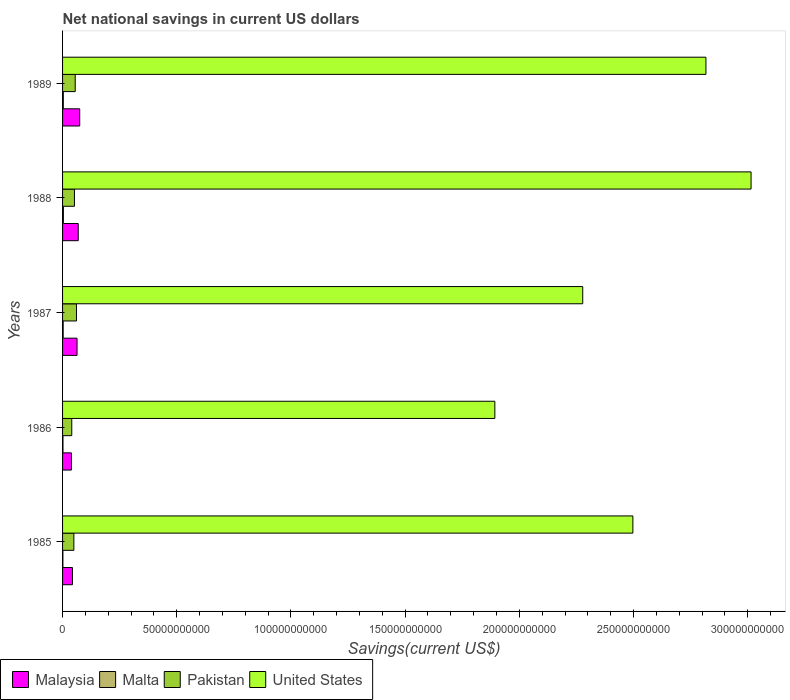How many groups of bars are there?
Provide a succinct answer. 5. How many bars are there on the 1st tick from the top?
Make the answer very short. 4. How many bars are there on the 1st tick from the bottom?
Offer a terse response. 4. In how many cases, is the number of bars for a given year not equal to the number of legend labels?
Make the answer very short. 0. What is the net national savings in Pakistan in 1987?
Keep it short and to the point. 6.09e+09. Across all years, what is the maximum net national savings in Pakistan?
Provide a succinct answer. 6.09e+09. Across all years, what is the minimum net national savings in Malta?
Make the answer very short. 1.41e+08. In which year was the net national savings in Pakistan minimum?
Ensure brevity in your answer.  1986. What is the total net national savings in United States in the graph?
Your response must be concise. 1.25e+12. What is the difference between the net national savings in Pakistan in 1987 and that in 1989?
Give a very brief answer. 5.49e+08. What is the difference between the net national savings in Malaysia in 1989 and the net national savings in United States in 1986?
Your response must be concise. -1.82e+11. What is the average net national savings in Malaysia per year?
Provide a short and direct response. 5.79e+09. In the year 1987, what is the difference between the net national savings in Pakistan and net national savings in Malta?
Keep it short and to the point. 5.83e+09. In how many years, is the net national savings in Malta greater than 70000000000 US$?
Offer a very short reply. 0. What is the ratio of the net national savings in Malaysia in 1988 to that in 1989?
Provide a short and direct response. 0.91. Is the net national savings in Malaysia in 1986 less than that in 1988?
Offer a very short reply. Yes. What is the difference between the highest and the second highest net national savings in Pakistan?
Your response must be concise. 5.49e+08. What is the difference between the highest and the lowest net national savings in Malaysia?
Your answer should be very brief. 3.62e+09. Is the sum of the net national savings in United States in 1986 and 1989 greater than the maximum net national savings in Malaysia across all years?
Offer a terse response. Yes. What does the 3rd bar from the bottom in 1986 represents?
Your answer should be compact. Pakistan. Is it the case that in every year, the sum of the net national savings in United States and net national savings in Malta is greater than the net national savings in Malaysia?
Make the answer very short. Yes. How many years are there in the graph?
Your answer should be very brief. 5. What is the difference between two consecutive major ticks on the X-axis?
Keep it short and to the point. 5.00e+1. Where does the legend appear in the graph?
Keep it short and to the point. Bottom left. What is the title of the graph?
Give a very brief answer. Net national savings in current US dollars. What is the label or title of the X-axis?
Give a very brief answer. Savings(current US$). What is the Savings(current US$) in Malaysia in 1985?
Offer a very short reply. 4.33e+09. What is the Savings(current US$) in Malta in 1985?
Keep it short and to the point. 1.41e+08. What is the Savings(current US$) in Pakistan in 1985?
Provide a succinct answer. 4.95e+09. What is the Savings(current US$) of United States in 1985?
Provide a succinct answer. 2.50e+11. What is the Savings(current US$) in Malaysia in 1986?
Give a very brief answer. 3.89e+09. What is the Savings(current US$) of Malta in 1986?
Give a very brief answer. 1.83e+08. What is the Savings(current US$) of Pakistan in 1986?
Provide a succinct answer. 4.03e+09. What is the Savings(current US$) in United States in 1986?
Provide a short and direct response. 1.89e+11. What is the Savings(current US$) in Malaysia in 1987?
Offer a very short reply. 6.34e+09. What is the Savings(current US$) in Malta in 1987?
Offer a very short reply. 2.65e+08. What is the Savings(current US$) in Pakistan in 1987?
Provide a short and direct response. 6.09e+09. What is the Savings(current US$) in United States in 1987?
Your answer should be very brief. 2.28e+11. What is the Savings(current US$) in Malaysia in 1988?
Provide a succinct answer. 6.86e+09. What is the Savings(current US$) of Malta in 1988?
Your response must be concise. 3.62e+08. What is the Savings(current US$) in Pakistan in 1988?
Your response must be concise. 5.20e+09. What is the Savings(current US$) in United States in 1988?
Your answer should be compact. 3.01e+11. What is the Savings(current US$) of Malaysia in 1989?
Give a very brief answer. 7.51e+09. What is the Savings(current US$) in Malta in 1989?
Your response must be concise. 3.23e+08. What is the Savings(current US$) in Pakistan in 1989?
Your answer should be very brief. 5.54e+09. What is the Savings(current US$) in United States in 1989?
Provide a short and direct response. 2.82e+11. Across all years, what is the maximum Savings(current US$) in Malaysia?
Your answer should be compact. 7.51e+09. Across all years, what is the maximum Savings(current US$) in Malta?
Give a very brief answer. 3.62e+08. Across all years, what is the maximum Savings(current US$) of Pakistan?
Provide a succinct answer. 6.09e+09. Across all years, what is the maximum Savings(current US$) in United States?
Your answer should be compact. 3.01e+11. Across all years, what is the minimum Savings(current US$) of Malaysia?
Your answer should be very brief. 3.89e+09. Across all years, what is the minimum Savings(current US$) of Malta?
Ensure brevity in your answer.  1.41e+08. Across all years, what is the minimum Savings(current US$) of Pakistan?
Your answer should be compact. 4.03e+09. Across all years, what is the minimum Savings(current US$) of United States?
Ensure brevity in your answer.  1.89e+11. What is the total Savings(current US$) in Malaysia in the graph?
Make the answer very short. 2.89e+1. What is the total Savings(current US$) of Malta in the graph?
Your answer should be compact. 1.28e+09. What is the total Savings(current US$) of Pakistan in the graph?
Ensure brevity in your answer.  2.58e+1. What is the total Savings(current US$) in United States in the graph?
Provide a short and direct response. 1.25e+12. What is the difference between the Savings(current US$) in Malaysia in 1985 and that in 1986?
Your response must be concise. 4.40e+08. What is the difference between the Savings(current US$) in Malta in 1985 and that in 1986?
Provide a short and direct response. -4.16e+07. What is the difference between the Savings(current US$) in Pakistan in 1985 and that in 1986?
Make the answer very short. 9.20e+08. What is the difference between the Savings(current US$) of United States in 1985 and that in 1986?
Your answer should be compact. 6.04e+1. What is the difference between the Savings(current US$) of Malaysia in 1985 and that in 1987?
Provide a short and direct response. -2.01e+09. What is the difference between the Savings(current US$) in Malta in 1985 and that in 1987?
Your response must be concise. -1.24e+08. What is the difference between the Savings(current US$) in Pakistan in 1985 and that in 1987?
Give a very brief answer. -1.14e+09. What is the difference between the Savings(current US$) of United States in 1985 and that in 1987?
Your answer should be very brief. 2.20e+1. What is the difference between the Savings(current US$) in Malaysia in 1985 and that in 1988?
Your answer should be compact. -2.53e+09. What is the difference between the Savings(current US$) in Malta in 1985 and that in 1988?
Ensure brevity in your answer.  -2.21e+08. What is the difference between the Savings(current US$) of Pakistan in 1985 and that in 1988?
Your answer should be compact. -2.55e+08. What is the difference between the Savings(current US$) of United States in 1985 and that in 1988?
Provide a short and direct response. -5.17e+1. What is the difference between the Savings(current US$) in Malaysia in 1985 and that in 1989?
Provide a short and direct response. -3.18e+09. What is the difference between the Savings(current US$) in Malta in 1985 and that in 1989?
Offer a very short reply. -1.82e+08. What is the difference between the Savings(current US$) of Pakistan in 1985 and that in 1989?
Your answer should be very brief. -5.95e+08. What is the difference between the Savings(current US$) in United States in 1985 and that in 1989?
Provide a short and direct response. -3.20e+1. What is the difference between the Savings(current US$) of Malaysia in 1986 and that in 1987?
Your response must be concise. -2.45e+09. What is the difference between the Savings(current US$) in Malta in 1986 and that in 1987?
Your answer should be compact. -8.21e+07. What is the difference between the Savings(current US$) in Pakistan in 1986 and that in 1987?
Ensure brevity in your answer.  -2.06e+09. What is the difference between the Savings(current US$) of United States in 1986 and that in 1987?
Offer a terse response. -3.85e+1. What is the difference between the Savings(current US$) of Malaysia in 1986 and that in 1988?
Your answer should be compact. -2.97e+09. What is the difference between the Savings(current US$) in Malta in 1986 and that in 1988?
Offer a terse response. -1.79e+08. What is the difference between the Savings(current US$) in Pakistan in 1986 and that in 1988?
Offer a very short reply. -1.18e+09. What is the difference between the Savings(current US$) in United States in 1986 and that in 1988?
Provide a succinct answer. -1.12e+11. What is the difference between the Savings(current US$) of Malaysia in 1986 and that in 1989?
Your answer should be compact. -3.62e+09. What is the difference between the Savings(current US$) in Malta in 1986 and that in 1989?
Offer a terse response. -1.40e+08. What is the difference between the Savings(current US$) of Pakistan in 1986 and that in 1989?
Your response must be concise. -1.52e+09. What is the difference between the Savings(current US$) in United States in 1986 and that in 1989?
Your answer should be compact. -9.24e+1. What is the difference between the Savings(current US$) of Malaysia in 1987 and that in 1988?
Offer a terse response. -5.20e+08. What is the difference between the Savings(current US$) in Malta in 1987 and that in 1988?
Make the answer very short. -9.72e+07. What is the difference between the Savings(current US$) in Pakistan in 1987 and that in 1988?
Provide a succinct answer. 8.89e+08. What is the difference between the Savings(current US$) in United States in 1987 and that in 1988?
Offer a terse response. -7.37e+1. What is the difference between the Savings(current US$) in Malaysia in 1987 and that in 1989?
Make the answer very short. -1.17e+09. What is the difference between the Savings(current US$) in Malta in 1987 and that in 1989?
Your answer should be compact. -5.83e+07. What is the difference between the Savings(current US$) of Pakistan in 1987 and that in 1989?
Your answer should be compact. 5.49e+08. What is the difference between the Savings(current US$) of United States in 1987 and that in 1989?
Your response must be concise. -5.39e+1. What is the difference between the Savings(current US$) in Malaysia in 1988 and that in 1989?
Keep it short and to the point. -6.50e+08. What is the difference between the Savings(current US$) of Malta in 1988 and that in 1989?
Offer a very short reply. 3.90e+07. What is the difference between the Savings(current US$) of Pakistan in 1988 and that in 1989?
Ensure brevity in your answer.  -3.40e+08. What is the difference between the Savings(current US$) of United States in 1988 and that in 1989?
Give a very brief answer. 1.98e+1. What is the difference between the Savings(current US$) in Malaysia in 1985 and the Savings(current US$) in Malta in 1986?
Offer a very short reply. 4.15e+09. What is the difference between the Savings(current US$) in Malaysia in 1985 and the Savings(current US$) in Pakistan in 1986?
Your answer should be very brief. 3.06e+08. What is the difference between the Savings(current US$) in Malaysia in 1985 and the Savings(current US$) in United States in 1986?
Your answer should be compact. -1.85e+11. What is the difference between the Savings(current US$) of Malta in 1985 and the Savings(current US$) of Pakistan in 1986?
Offer a terse response. -3.89e+09. What is the difference between the Savings(current US$) in Malta in 1985 and the Savings(current US$) in United States in 1986?
Provide a succinct answer. -1.89e+11. What is the difference between the Savings(current US$) in Pakistan in 1985 and the Savings(current US$) in United States in 1986?
Your answer should be very brief. -1.84e+11. What is the difference between the Savings(current US$) of Malaysia in 1985 and the Savings(current US$) of Malta in 1987?
Keep it short and to the point. 4.07e+09. What is the difference between the Savings(current US$) of Malaysia in 1985 and the Savings(current US$) of Pakistan in 1987?
Keep it short and to the point. -1.76e+09. What is the difference between the Savings(current US$) of Malaysia in 1985 and the Savings(current US$) of United States in 1987?
Make the answer very short. -2.23e+11. What is the difference between the Savings(current US$) of Malta in 1985 and the Savings(current US$) of Pakistan in 1987?
Provide a short and direct response. -5.95e+09. What is the difference between the Savings(current US$) of Malta in 1985 and the Savings(current US$) of United States in 1987?
Your answer should be compact. -2.28e+11. What is the difference between the Savings(current US$) in Pakistan in 1985 and the Savings(current US$) in United States in 1987?
Your response must be concise. -2.23e+11. What is the difference between the Savings(current US$) of Malaysia in 1985 and the Savings(current US$) of Malta in 1988?
Ensure brevity in your answer.  3.97e+09. What is the difference between the Savings(current US$) of Malaysia in 1985 and the Savings(current US$) of Pakistan in 1988?
Provide a short and direct response. -8.70e+08. What is the difference between the Savings(current US$) of Malaysia in 1985 and the Savings(current US$) of United States in 1988?
Your answer should be compact. -2.97e+11. What is the difference between the Savings(current US$) of Malta in 1985 and the Savings(current US$) of Pakistan in 1988?
Offer a terse response. -5.06e+09. What is the difference between the Savings(current US$) in Malta in 1985 and the Savings(current US$) in United States in 1988?
Make the answer very short. -3.01e+11. What is the difference between the Savings(current US$) of Pakistan in 1985 and the Savings(current US$) of United States in 1988?
Ensure brevity in your answer.  -2.97e+11. What is the difference between the Savings(current US$) of Malaysia in 1985 and the Savings(current US$) of Malta in 1989?
Your response must be concise. 4.01e+09. What is the difference between the Savings(current US$) in Malaysia in 1985 and the Savings(current US$) in Pakistan in 1989?
Your answer should be compact. -1.21e+09. What is the difference between the Savings(current US$) in Malaysia in 1985 and the Savings(current US$) in United States in 1989?
Provide a short and direct response. -2.77e+11. What is the difference between the Savings(current US$) in Malta in 1985 and the Savings(current US$) in Pakistan in 1989?
Give a very brief answer. -5.40e+09. What is the difference between the Savings(current US$) of Malta in 1985 and the Savings(current US$) of United States in 1989?
Ensure brevity in your answer.  -2.82e+11. What is the difference between the Savings(current US$) in Pakistan in 1985 and the Savings(current US$) in United States in 1989?
Keep it short and to the point. -2.77e+11. What is the difference between the Savings(current US$) of Malaysia in 1986 and the Savings(current US$) of Malta in 1987?
Provide a short and direct response. 3.63e+09. What is the difference between the Savings(current US$) in Malaysia in 1986 and the Savings(current US$) in Pakistan in 1987?
Your answer should be compact. -2.20e+09. What is the difference between the Savings(current US$) of Malaysia in 1986 and the Savings(current US$) of United States in 1987?
Your answer should be very brief. -2.24e+11. What is the difference between the Savings(current US$) in Malta in 1986 and the Savings(current US$) in Pakistan in 1987?
Ensure brevity in your answer.  -5.91e+09. What is the difference between the Savings(current US$) of Malta in 1986 and the Savings(current US$) of United States in 1987?
Keep it short and to the point. -2.28e+11. What is the difference between the Savings(current US$) of Pakistan in 1986 and the Savings(current US$) of United States in 1987?
Ensure brevity in your answer.  -2.24e+11. What is the difference between the Savings(current US$) of Malaysia in 1986 and the Savings(current US$) of Malta in 1988?
Offer a very short reply. 3.53e+09. What is the difference between the Savings(current US$) in Malaysia in 1986 and the Savings(current US$) in Pakistan in 1988?
Make the answer very short. -1.31e+09. What is the difference between the Savings(current US$) of Malaysia in 1986 and the Savings(current US$) of United States in 1988?
Your answer should be compact. -2.98e+11. What is the difference between the Savings(current US$) in Malta in 1986 and the Savings(current US$) in Pakistan in 1988?
Keep it short and to the point. -5.02e+09. What is the difference between the Savings(current US$) in Malta in 1986 and the Savings(current US$) in United States in 1988?
Your response must be concise. -3.01e+11. What is the difference between the Savings(current US$) in Pakistan in 1986 and the Savings(current US$) in United States in 1988?
Give a very brief answer. -2.97e+11. What is the difference between the Savings(current US$) of Malaysia in 1986 and the Savings(current US$) of Malta in 1989?
Keep it short and to the point. 3.57e+09. What is the difference between the Savings(current US$) in Malaysia in 1986 and the Savings(current US$) in Pakistan in 1989?
Your response must be concise. -1.65e+09. What is the difference between the Savings(current US$) of Malaysia in 1986 and the Savings(current US$) of United States in 1989?
Your response must be concise. -2.78e+11. What is the difference between the Savings(current US$) of Malta in 1986 and the Savings(current US$) of Pakistan in 1989?
Ensure brevity in your answer.  -5.36e+09. What is the difference between the Savings(current US$) of Malta in 1986 and the Savings(current US$) of United States in 1989?
Offer a very short reply. -2.82e+11. What is the difference between the Savings(current US$) in Pakistan in 1986 and the Savings(current US$) in United States in 1989?
Offer a terse response. -2.78e+11. What is the difference between the Savings(current US$) of Malaysia in 1987 and the Savings(current US$) of Malta in 1988?
Give a very brief answer. 5.98e+09. What is the difference between the Savings(current US$) of Malaysia in 1987 and the Savings(current US$) of Pakistan in 1988?
Your answer should be compact. 1.14e+09. What is the difference between the Savings(current US$) of Malaysia in 1987 and the Savings(current US$) of United States in 1988?
Your response must be concise. -2.95e+11. What is the difference between the Savings(current US$) of Malta in 1987 and the Savings(current US$) of Pakistan in 1988?
Provide a succinct answer. -4.94e+09. What is the difference between the Savings(current US$) of Malta in 1987 and the Savings(current US$) of United States in 1988?
Your response must be concise. -3.01e+11. What is the difference between the Savings(current US$) in Pakistan in 1987 and the Savings(current US$) in United States in 1988?
Give a very brief answer. -2.95e+11. What is the difference between the Savings(current US$) in Malaysia in 1987 and the Savings(current US$) in Malta in 1989?
Your answer should be very brief. 6.02e+09. What is the difference between the Savings(current US$) of Malaysia in 1987 and the Savings(current US$) of Pakistan in 1989?
Your response must be concise. 7.97e+08. What is the difference between the Savings(current US$) of Malaysia in 1987 and the Savings(current US$) of United States in 1989?
Provide a short and direct response. -2.75e+11. What is the difference between the Savings(current US$) in Malta in 1987 and the Savings(current US$) in Pakistan in 1989?
Offer a terse response. -5.28e+09. What is the difference between the Savings(current US$) of Malta in 1987 and the Savings(current US$) of United States in 1989?
Provide a short and direct response. -2.81e+11. What is the difference between the Savings(current US$) in Pakistan in 1987 and the Savings(current US$) in United States in 1989?
Your response must be concise. -2.76e+11. What is the difference between the Savings(current US$) of Malaysia in 1988 and the Savings(current US$) of Malta in 1989?
Provide a short and direct response. 6.54e+09. What is the difference between the Savings(current US$) in Malaysia in 1988 and the Savings(current US$) in Pakistan in 1989?
Offer a terse response. 1.32e+09. What is the difference between the Savings(current US$) in Malaysia in 1988 and the Savings(current US$) in United States in 1989?
Your answer should be compact. -2.75e+11. What is the difference between the Savings(current US$) in Malta in 1988 and the Savings(current US$) in Pakistan in 1989?
Your answer should be very brief. -5.18e+09. What is the difference between the Savings(current US$) in Malta in 1988 and the Savings(current US$) in United States in 1989?
Keep it short and to the point. -2.81e+11. What is the difference between the Savings(current US$) in Pakistan in 1988 and the Savings(current US$) in United States in 1989?
Offer a very short reply. -2.77e+11. What is the average Savings(current US$) of Malaysia per year?
Make the answer very short. 5.79e+09. What is the average Savings(current US$) in Malta per year?
Make the answer very short. 2.55e+08. What is the average Savings(current US$) of Pakistan per year?
Provide a short and direct response. 5.16e+09. What is the average Savings(current US$) in United States per year?
Keep it short and to the point. 2.50e+11. In the year 1985, what is the difference between the Savings(current US$) in Malaysia and Savings(current US$) in Malta?
Offer a very short reply. 4.19e+09. In the year 1985, what is the difference between the Savings(current US$) of Malaysia and Savings(current US$) of Pakistan?
Ensure brevity in your answer.  -6.14e+08. In the year 1985, what is the difference between the Savings(current US$) in Malaysia and Savings(current US$) in United States?
Offer a very short reply. -2.45e+11. In the year 1985, what is the difference between the Savings(current US$) of Malta and Savings(current US$) of Pakistan?
Offer a very short reply. -4.81e+09. In the year 1985, what is the difference between the Savings(current US$) in Malta and Savings(current US$) in United States?
Your answer should be compact. -2.50e+11. In the year 1985, what is the difference between the Savings(current US$) in Pakistan and Savings(current US$) in United States?
Give a very brief answer. -2.45e+11. In the year 1986, what is the difference between the Savings(current US$) of Malaysia and Savings(current US$) of Malta?
Offer a very short reply. 3.71e+09. In the year 1986, what is the difference between the Savings(current US$) of Malaysia and Savings(current US$) of Pakistan?
Your answer should be very brief. -1.35e+08. In the year 1986, what is the difference between the Savings(current US$) of Malaysia and Savings(current US$) of United States?
Provide a short and direct response. -1.85e+11. In the year 1986, what is the difference between the Savings(current US$) in Malta and Savings(current US$) in Pakistan?
Provide a succinct answer. -3.84e+09. In the year 1986, what is the difference between the Savings(current US$) in Malta and Savings(current US$) in United States?
Your answer should be compact. -1.89e+11. In the year 1986, what is the difference between the Savings(current US$) in Pakistan and Savings(current US$) in United States?
Make the answer very short. -1.85e+11. In the year 1987, what is the difference between the Savings(current US$) of Malaysia and Savings(current US$) of Malta?
Provide a succinct answer. 6.07e+09. In the year 1987, what is the difference between the Savings(current US$) of Malaysia and Savings(current US$) of Pakistan?
Your answer should be compact. 2.47e+08. In the year 1987, what is the difference between the Savings(current US$) in Malaysia and Savings(current US$) in United States?
Keep it short and to the point. -2.21e+11. In the year 1987, what is the difference between the Savings(current US$) of Malta and Savings(current US$) of Pakistan?
Offer a very short reply. -5.83e+09. In the year 1987, what is the difference between the Savings(current US$) of Malta and Savings(current US$) of United States?
Your response must be concise. -2.27e+11. In the year 1987, what is the difference between the Savings(current US$) of Pakistan and Savings(current US$) of United States?
Your answer should be compact. -2.22e+11. In the year 1988, what is the difference between the Savings(current US$) in Malaysia and Savings(current US$) in Malta?
Offer a terse response. 6.50e+09. In the year 1988, what is the difference between the Savings(current US$) in Malaysia and Savings(current US$) in Pakistan?
Ensure brevity in your answer.  1.66e+09. In the year 1988, what is the difference between the Savings(current US$) in Malaysia and Savings(current US$) in United States?
Offer a very short reply. -2.95e+11. In the year 1988, what is the difference between the Savings(current US$) of Malta and Savings(current US$) of Pakistan?
Your answer should be very brief. -4.84e+09. In the year 1988, what is the difference between the Savings(current US$) in Malta and Savings(current US$) in United States?
Give a very brief answer. -3.01e+11. In the year 1988, what is the difference between the Savings(current US$) in Pakistan and Savings(current US$) in United States?
Ensure brevity in your answer.  -2.96e+11. In the year 1989, what is the difference between the Savings(current US$) of Malaysia and Savings(current US$) of Malta?
Provide a short and direct response. 7.19e+09. In the year 1989, what is the difference between the Savings(current US$) in Malaysia and Savings(current US$) in Pakistan?
Your answer should be very brief. 1.97e+09. In the year 1989, what is the difference between the Savings(current US$) in Malaysia and Savings(current US$) in United States?
Provide a short and direct response. -2.74e+11. In the year 1989, what is the difference between the Savings(current US$) of Malta and Savings(current US$) of Pakistan?
Your response must be concise. -5.22e+09. In the year 1989, what is the difference between the Savings(current US$) in Malta and Savings(current US$) in United States?
Offer a terse response. -2.81e+11. In the year 1989, what is the difference between the Savings(current US$) of Pakistan and Savings(current US$) of United States?
Make the answer very short. -2.76e+11. What is the ratio of the Savings(current US$) in Malaysia in 1985 to that in 1986?
Ensure brevity in your answer.  1.11. What is the ratio of the Savings(current US$) in Malta in 1985 to that in 1986?
Provide a succinct answer. 0.77. What is the ratio of the Savings(current US$) of Pakistan in 1985 to that in 1986?
Give a very brief answer. 1.23. What is the ratio of the Savings(current US$) of United States in 1985 to that in 1986?
Your answer should be very brief. 1.32. What is the ratio of the Savings(current US$) of Malaysia in 1985 to that in 1987?
Keep it short and to the point. 0.68. What is the ratio of the Savings(current US$) in Malta in 1985 to that in 1987?
Provide a succinct answer. 0.53. What is the ratio of the Savings(current US$) in Pakistan in 1985 to that in 1987?
Offer a terse response. 0.81. What is the ratio of the Savings(current US$) of United States in 1985 to that in 1987?
Your answer should be very brief. 1.1. What is the ratio of the Savings(current US$) in Malaysia in 1985 to that in 1988?
Offer a terse response. 0.63. What is the ratio of the Savings(current US$) of Malta in 1985 to that in 1988?
Offer a very short reply. 0.39. What is the ratio of the Savings(current US$) of Pakistan in 1985 to that in 1988?
Make the answer very short. 0.95. What is the ratio of the Savings(current US$) of United States in 1985 to that in 1988?
Provide a short and direct response. 0.83. What is the ratio of the Savings(current US$) in Malaysia in 1985 to that in 1989?
Make the answer very short. 0.58. What is the ratio of the Savings(current US$) of Malta in 1985 to that in 1989?
Offer a very short reply. 0.44. What is the ratio of the Savings(current US$) of Pakistan in 1985 to that in 1989?
Ensure brevity in your answer.  0.89. What is the ratio of the Savings(current US$) of United States in 1985 to that in 1989?
Your response must be concise. 0.89. What is the ratio of the Savings(current US$) of Malaysia in 1986 to that in 1987?
Ensure brevity in your answer.  0.61. What is the ratio of the Savings(current US$) of Malta in 1986 to that in 1987?
Provide a short and direct response. 0.69. What is the ratio of the Savings(current US$) in Pakistan in 1986 to that in 1987?
Provide a succinct answer. 0.66. What is the ratio of the Savings(current US$) of United States in 1986 to that in 1987?
Provide a short and direct response. 0.83. What is the ratio of the Savings(current US$) in Malaysia in 1986 to that in 1988?
Give a very brief answer. 0.57. What is the ratio of the Savings(current US$) of Malta in 1986 to that in 1988?
Make the answer very short. 0.51. What is the ratio of the Savings(current US$) of Pakistan in 1986 to that in 1988?
Give a very brief answer. 0.77. What is the ratio of the Savings(current US$) in United States in 1986 to that in 1988?
Your answer should be very brief. 0.63. What is the ratio of the Savings(current US$) of Malaysia in 1986 to that in 1989?
Make the answer very short. 0.52. What is the ratio of the Savings(current US$) of Malta in 1986 to that in 1989?
Ensure brevity in your answer.  0.57. What is the ratio of the Savings(current US$) of Pakistan in 1986 to that in 1989?
Ensure brevity in your answer.  0.73. What is the ratio of the Savings(current US$) of United States in 1986 to that in 1989?
Ensure brevity in your answer.  0.67. What is the ratio of the Savings(current US$) in Malaysia in 1987 to that in 1988?
Give a very brief answer. 0.92. What is the ratio of the Savings(current US$) of Malta in 1987 to that in 1988?
Provide a succinct answer. 0.73. What is the ratio of the Savings(current US$) in Pakistan in 1987 to that in 1988?
Offer a terse response. 1.17. What is the ratio of the Savings(current US$) of United States in 1987 to that in 1988?
Your answer should be compact. 0.76. What is the ratio of the Savings(current US$) of Malaysia in 1987 to that in 1989?
Your answer should be compact. 0.84. What is the ratio of the Savings(current US$) in Malta in 1987 to that in 1989?
Provide a short and direct response. 0.82. What is the ratio of the Savings(current US$) of Pakistan in 1987 to that in 1989?
Keep it short and to the point. 1.1. What is the ratio of the Savings(current US$) in United States in 1987 to that in 1989?
Your answer should be very brief. 0.81. What is the ratio of the Savings(current US$) of Malaysia in 1988 to that in 1989?
Provide a short and direct response. 0.91. What is the ratio of the Savings(current US$) in Malta in 1988 to that in 1989?
Your answer should be compact. 1.12. What is the ratio of the Savings(current US$) in Pakistan in 1988 to that in 1989?
Keep it short and to the point. 0.94. What is the ratio of the Savings(current US$) in United States in 1988 to that in 1989?
Offer a terse response. 1.07. What is the difference between the highest and the second highest Savings(current US$) of Malaysia?
Your response must be concise. 6.50e+08. What is the difference between the highest and the second highest Savings(current US$) of Malta?
Your answer should be compact. 3.90e+07. What is the difference between the highest and the second highest Savings(current US$) in Pakistan?
Make the answer very short. 5.49e+08. What is the difference between the highest and the second highest Savings(current US$) in United States?
Your answer should be very brief. 1.98e+1. What is the difference between the highest and the lowest Savings(current US$) in Malaysia?
Offer a very short reply. 3.62e+09. What is the difference between the highest and the lowest Savings(current US$) in Malta?
Offer a terse response. 2.21e+08. What is the difference between the highest and the lowest Savings(current US$) in Pakistan?
Ensure brevity in your answer.  2.06e+09. What is the difference between the highest and the lowest Savings(current US$) in United States?
Your answer should be very brief. 1.12e+11. 